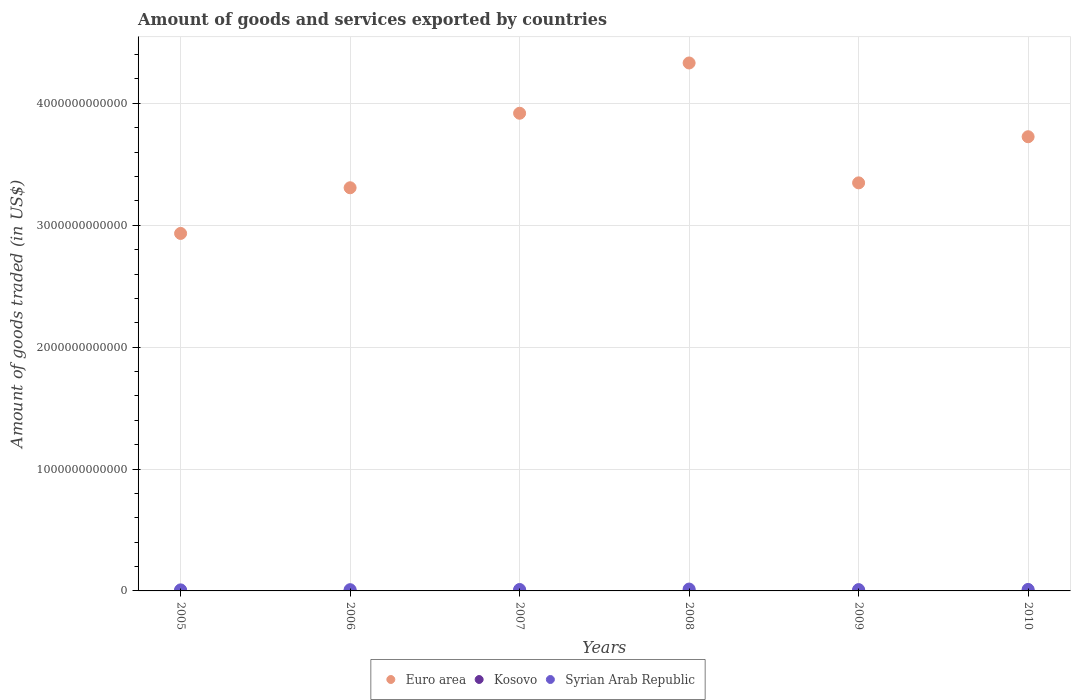How many different coloured dotlines are there?
Keep it short and to the point. 3. Is the number of dotlines equal to the number of legend labels?
Keep it short and to the point. Yes. What is the total amount of goods and services exported in Kosovo in 2005?
Keep it short and to the point. 7.96e+07. Across all years, what is the maximum total amount of goods and services exported in Syrian Arab Republic?
Your answer should be very brief. 1.53e+1. Across all years, what is the minimum total amount of goods and services exported in Euro area?
Ensure brevity in your answer.  2.93e+12. What is the total total amount of goods and services exported in Syrian Arab Republic in the graph?
Your answer should be compact. 6.91e+1. What is the difference between the total amount of goods and services exported in Euro area in 2005 and that in 2009?
Make the answer very short. -4.15e+11. What is the difference between the total amount of goods and services exported in Syrian Arab Republic in 2010 and the total amount of goods and services exported in Kosovo in 2009?
Make the answer very short. 1.20e+1. What is the average total amount of goods and services exported in Syrian Arab Republic per year?
Offer a terse response. 1.15e+1. In the year 2008, what is the difference between the total amount of goods and services exported in Kosovo and total amount of goods and services exported in Syrian Arab Republic?
Your answer should be very brief. -1.52e+1. What is the ratio of the total amount of goods and services exported in Syrian Arab Republic in 2005 to that in 2006?
Keep it short and to the point. 0.84. What is the difference between the highest and the second highest total amount of goods and services exported in Euro area?
Keep it short and to the point. 4.12e+11. What is the difference between the highest and the lowest total amount of goods and services exported in Euro area?
Offer a terse response. 1.40e+12. Does the total amount of goods and services exported in Euro area monotonically increase over the years?
Give a very brief answer. No. What is the difference between two consecutive major ticks on the Y-axis?
Offer a very short reply. 1.00e+12. Does the graph contain any zero values?
Your answer should be very brief. No. Does the graph contain grids?
Provide a succinct answer. Yes. How many legend labels are there?
Your answer should be compact. 3. What is the title of the graph?
Your response must be concise. Amount of goods and services exported by countries. What is the label or title of the X-axis?
Your answer should be very brief. Years. What is the label or title of the Y-axis?
Your answer should be very brief. Amount of goods traded (in US$). What is the Amount of goods traded (in US$) in Euro area in 2005?
Your answer should be compact. 2.93e+12. What is the Amount of goods traded (in US$) of Kosovo in 2005?
Keep it short and to the point. 7.96e+07. What is the Amount of goods traded (in US$) of Syrian Arab Republic in 2005?
Offer a very short reply. 8.60e+09. What is the Amount of goods traded (in US$) of Euro area in 2006?
Make the answer very short. 3.31e+12. What is the Amount of goods traded (in US$) of Kosovo in 2006?
Your answer should be compact. 1.24e+08. What is the Amount of goods traded (in US$) in Syrian Arab Republic in 2006?
Your answer should be compact. 1.02e+1. What is the Amount of goods traded (in US$) in Euro area in 2007?
Your answer should be very brief. 3.92e+12. What is the Amount of goods traded (in US$) of Kosovo in 2007?
Ensure brevity in your answer.  1.82e+08. What is the Amount of goods traded (in US$) of Syrian Arab Republic in 2007?
Make the answer very short. 1.18e+1. What is the Amount of goods traded (in US$) in Euro area in 2008?
Your response must be concise. 4.33e+12. What is the Amount of goods traded (in US$) in Kosovo in 2008?
Make the answer very short. 1.76e+08. What is the Amount of goods traded (in US$) of Syrian Arab Republic in 2008?
Ensure brevity in your answer.  1.53e+1. What is the Amount of goods traded (in US$) of Euro area in 2009?
Offer a very short reply. 3.35e+12. What is the Amount of goods traded (in US$) of Kosovo in 2009?
Keep it short and to the point. 2.43e+08. What is the Amount of goods traded (in US$) in Syrian Arab Republic in 2009?
Your answer should be compact. 1.09e+1. What is the Amount of goods traded (in US$) of Euro area in 2010?
Ensure brevity in your answer.  3.73e+12. What is the Amount of goods traded (in US$) of Kosovo in 2010?
Ensure brevity in your answer.  3.95e+08. What is the Amount of goods traded (in US$) in Syrian Arab Republic in 2010?
Keep it short and to the point. 1.23e+1. Across all years, what is the maximum Amount of goods traded (in US$) of Euro area?
Provide a short and direct response. 4.33e+12. Across all years, what is the maximum Amount of goods traded (in US$) in Kosovo?
Your answer should be compact. 3.95e+08. Across all years, what is the maximum Amount of goods traded (in US$) of Syrian Arab Republic?
Keep it short and to the point. 1.53e+1. Across all years, what is the minimum Amount of goods traded (in US$) in Euro area?
Ensure brevity in your answer.  2.93e+12. Across all years, what is the minimum Amount of goods traded (in US$) in Kosovo?
Your answer should be very brief. 7.96e+07. Across all years, what is the minimum Amount of goods traded (in US$) in Syrian Arab Republic?
Offer a very short reply. 8.60e+09. What is the total Amount of goods traded (in US$) of Euro area in the graph?
Provide a short and direct response. 2.16e+13. What is the total Amount of goods traded (in US$) in Kosovo in the graph?
Ensure brevity in your answer.  1.20e+09. What is the total Amount of goods traded (in US$) in Syrian Arab Republic in the graph?
Make the answer very short. 6.91e+1. What is the difference between the Amount of goods traded (in US$) of Euro area in 2005 and that in 2006?
Your response must be concise. -3.75e+11. What is the difference between the Amount of goods traded (in US$) of Kosovo in 2005 and that in 2006?
Give a very brief answer. -4.40e+07. What is the difference between the Amount of goods traded (in US$) of Syrian Arab Republic in 2005 and that in 2006?
Your response must be concise. -1.64e+09. What is the difference between the Amount of goods traded (in US$) of Euro area in 2005 and that in 2007?
Keep it short and to the point. -9.86e+11. What is the difference between the Amount of goods traded (in US$) of Kosovo in 2005 and that in 2007?
Your answer should be very brief. -1.02e+08. What is the difference between the Amount of goods traded (in US$) in Syrian Arab Republic in 2005 and that in 2007?
Offer a terse response. -3.15e+09. What is the difference between the Amount of goods traded (in US$) in Euro area in 2005 and that in 2008?
Offer a terse response. -1.40e+12. What is the difference between the Amount of goods traded (in US$) in Kosovo in 2005 and that in 2008?
Provide a short and direct response. -9.60e+07. What is the difference between the Amount of goods traded (in US$) in Syrian Arab Republic in 2005 and that in 2008?
Give a very brief answer. -6.73e+09. What is the difference between the Amount of goods traded (in US$) in Euro area in 2005 and that in 2009?
Your answer should be compact. -4.15e+11. What is the difference between the Amount of goods traded (in US$) of Kosovo in 2005 and that in 2009?
Keep it short and to the point. -1.63e+08. What is the difference between the Amount of goods traded (in US$) in Syrian Arab Republic in 2005 and that in 2009?
Make the answer very short. -2.28e+09. What is the difference between the Amount of goods traded (in US$) in Euro area in 2005 and that in 2010?
Provide a succinct answer. -7.93e+11. What is the difference between the Amount of goods traded (in US$) of Kosovo in 2005 and that in 2010?
Your answer should be compact. -3.15e+08. What is the difference between the Amount of goods traded (in US$) of Syrian Arab Republic in 2005 and that in 2010?
Offer a very short reply. -3.67e+09. What is the difference between the Amount of goods traded (in US$) of Euro area in 2006 and that in 2007?
Keep it short and to the point. -6.11e+11. What is the difference between the Amount of goods traded (in US$) in Kosovo in 2006 and that in 2007?
Your response must be concise. -5.80e+07. What is the difference between the Amount of goods traded (in US$) of Syrian Arab Republic in 2006 and that in 2007?
Your response must be concise. -1.51e+09. What is the difference between the Amount of goods traded (in US$) in Euro area in 2006 and that in 2008?
Offer a very short reply. -1.02e+12. What is the difference between the Amount of goods traded (in US$) of Kosovo in 2006 and that in 2008?
Provide a succinct answer. -5.21e+07. What is the difference between the Amount of goods traded (in US$) of Syrian Arab Republic in 2006 and that in 2008?
Offer a terse response. -5.09e+09. What is the difference between the Amount of goods traded (in US$) in Euro area in 2006 and that in 2009?
Ensure brevity in your answer.  -4.01e+1. What is the difference between the Amount of goods traded (in US$) in Kosovo in 2006 and that in 2009?
Your response must be concise. -1.19e+08. What is the difference between the Amount of goods traded (in US$) of Syrian Arab Republic in 2006 and that in 2009?
Your response must be concise. -6.39e+08. What is the difference between the Amount of goods traded (in US$) in Euro area in 2006 and that in 2010?
Your answer should be compact. -4.19e+11. What is the difference between the Amount of goods traded (in US$) of Kosovo in 2006 and that in 2010?
Give a very brief answer. -2.71e+08. What is the difference between the Amount of goods traded (in US$) of Syrian Arab Republic in 2006 and that in 2010?
Your response must be concise. -2.03e+09. What is the difference between the Amount of goods traded (in US$) in Euro area in 2007 and that in 2008?
Your answer should be very brief. -4.12e+11. What is the difference between the Amount of goods traded (in US$) of Kosovo in 2007 and that in 2008?
Provide a short and direct response. 5.88e+06. What is the difference between the Amount of goods traded (in US$) of Syrian Arab Republic in 2007 and that in 2008?
Your response must be concise. -3.58e+09. What is the difference between the Amount of goods traded (in US$) of Euro area in 2007 and that in 2009?
Provide a short and direct response. 5.71e+11. What is the difference between the Amount of goods traded (in US$) in Kosovo in 2007 and that in 2009?
Give a very brief answer. -6.15e+07. What is the difference between the Amount of goods traded (in US$) of Syrian Arab Republic in 2007 and that in 2009?
Keep it short and to the point. 8.72e+08. What is the difference between the Amount of goods traded (in US$) of Euro area in 2007 and that in 2010?
Make the answer very short. 1.93e+11. What is the difference between the Amount of goods traded (in US$) of Kosovo in 2007 and that in 2010?
Keep it short and to the point. -2.13e+08. What is the difference between the Amount of goods traded (in US$) of Syrian Arab Republic in 2007 and that in 2010?
Your answer should be compact. -5.17e+08. What is the difference between the Amount of goods traded (in US$) in Euro area in 2008 and that in 2009?
Your answer should be very brief. 9.84e+11. What is the difference between the Amount of goods traded (in US$) of Kosovo in 2008 and that in 2009?
Keep it short and to the point. -6.73e+07. What is the difference between the Amount of goods traded (in US$) of Syrian Arab Republic in 2008 and that in 2009?
Your response must be concise. 4.45e+09. What is the difference between the Amount of goods traded (in US$) in Euro area in 2008 and that in 2010?
Your response must be concise. 6.05e+11. What is the difference between the Amount of goods traded (in US$) of Kosovo in 2008 and that in 2010?
Provide a succinct answer. -2.19e+08. What is the difference between the Amount of goods traded (in US$) in Syrian Arab Republic in 2008 and that in 2010?
Your answer should be very brief. 3.06e+09. What is the difference between the Amount of goods traded (in US$) of Euro area in 2009 and that in 2010?
Your answer should be compact. -3.78e+11. What is the difference between the Amount of goods traded (in US$) of Kosovo in 2009 and that in 2010?
Make the answer very short. -1.52e+08. What is the difference between the Amount of goods traded (in US$) of Syrian Arab Republic in 2009 and that in 2010?
Ensure brevity in your answer.  -1.39e+09. What is the difference between the Amount of goods traded (in US$) in Euro area in 2005 and the Amount of goods traded (in US$) in Kosovo in 2006?
Your answer should be very brief. 2.93e+12. What is the difference between the Amount of goods traded (in US$) of Euro area in 2005 and the Amount of goods traded (in US$) of Syrian Arab Republic in 2006?
Make the answer very short. 2.92e+12. What is the difference between the Amount of goods traded (in US$) in Kosovo in 2005 and the Amount of goods traded (in US$) in Syrian Arab Republic in 2006?
Keep it short and to the point. -1.02e+1. What is the difference between the Amount of goods traded (in US$) of Euro area in 2005 and the Amount of goods traded (in US$) of Kosovo in 2007?
Make the answer very short. 2.93e+12. What is the difference between the Amount of goods traded (in US$) of Euro area in 2005 and the Amount of goods traded (in US$) of Syrian Arab Republic in 2007?
Your response must be concise. 2.92e+12. What is the difference between the Amount of goods traded (in US$) in Kosovo in 2005 and the Amount of goods traded (in US$) in Syrian Arab Republic in 2007?
Your response must be concise. -1.17e+1. What is the difference between the Amount of goods traded (in US$) of Euro area in 2005 and the Amount of goods traded (in US$) of Kosovo in 2008?
Keep it short and to the point. 2.93e+12. What is the difference between the Amount of goods traded (in US$) in Euro area in 2005 and the Amount of goods traded (in US$) in Syrian Arab Republic in 2008?
Make the answer very short. 2.92e+12. What is the difference between the Amount of goods traded (in US$) in Kosovo in 2005 and the Amount of goods traded (in US$) in Syrian Arab Republic in 2008?
Ensure brevity in your answer.  -1.53e+1. What is the difference between the Amount of goods traded (in US$) of Euro area in 2005 and the Amount of goods traded (in US$) of Kosovo in 2009?
Offer a terse response. 2.93e+12. What is the difference between the Amount of goods traded (in US$) of Euro area in 2005 and the Amount of goods traded (in US$) of Syrian Arab Republic in 2009?
Give a very brief answer. 2.92e+12. What is the difference between the Amount of goods traded (in US$) of Kosovo in 2005 and the Amount of goods traded (in US$) of Syrian Arab Republic in 2009?
Keep it short and to the point. -1.08e+1. What is the difference between the Amount of goods traded (in US$) of Euro area in 2005 and the Amount of goods traded (in US$) of Kosovo in 2010?
Your answer should be very brief. 2.93e+12. What is the difference between the Amount of goods traded (in US$) in Euro area in 2005 and the Amount of goods traded (in US$) in Syrian Arab Republic in 2010?
Provide a short and direct response. 2.92e+12. What is the difference between the Amount of goods traded (in US$) of Kosovo in 2005 and the Amount of goods traded (in US$) of Syrian Arab Republic in 2010?
Your response must be concise. -1.22e+1. What is the difference between the Amount of goods traded (in US$) in Euro area in 2006 and the Amount of goods traded (in US$) in Kosovo in 2007?
Your response must be concise. 3.31e+12. What is the difference between the Amount of goods traded (in US$) in Euro area in 2006 and the Amount of goods traded (in US$) in Syrian Arab Republic in 2007?
Your answer should be compact. 3.30e+12. What is the difference between the Amount of goods traded (in US$) of Kosovo in 2006 and the Amount of goods traded (in US$) of Syrian Arab Republic in 2007?
Keep it short and to the point. -1.16e+1. What is the difference between the Amount of goods traded (in US$) in Euro area in 2006 and the Amount of goods traded (in US$) in Kosovo in 2008?
Provide a succinct answer. 3.31e+12. What is the difference between the Amount of goods traded (in US$) in Euro area in 2006 and the Amount of goods traded (in US$) in Syrian Arab Republic in 2008?
Ensure brevity in your answer.  3.29e+12. What is the difference between the Amount of goods traded (in US$) of Kosovo in 2006 and the Amount of goods traded (in US$) of Syrian Arab Republic in 2008?
Make the answer very short. -1.52e+1. What is the difference between the Amount of goods traded (in US$) in Euro area in 2006 and the Amount of goods traded (in US$) in Kosovo in 2009?
Offer a terse response. 3.31e+12. What is the difference between the Amount of goods traded (in US$) of Euro area in 2006 and the Amount of goods traded (in US$) of Syrian Arab Republic in 2009?
Offer a terse response. 3.30e+12. What is the difference between the Amount of goods traded (in US$) of Kosovo in 2006 and the Amount of goods traded (in US$) of Syrian Arab Republic in 2009?
Provide a short and direct response. -1.08e+1. What is the difference between the Amount of goods traded (in US$) in Euro area in 2006 and the Amount of goods traded (in US$) in Kosovo in 2010?
Make the answer very short. 3.31e+12. What is the difference between the Amount of goods traded (in US$) of Euro area in 2006 and the Amount of goods traded (in US$) of Syrian Arab Republic in 2010?
Make the answer very short. 3.30e+12. What is the difference between the Amount of goods traded (in US$) of Kosovo in 2006 and the Amount of goods traded (in US$) of Syrian Arab Republic in 2010?
Offer a very short reply. -1.21e+1. What is the difference between the Amount of goods traded (in US$) of Euro area in 2007 and the Amount of goods traded (in US$) of Kosovo in 2008?
Your answer should be compact. 3.92e+12. What is the difference between the Amount of goods traded (in US$) in Euro area in 2007 and the Amount of goods traded (in US$) in Syrian Arab Republic in 2008?
Give a very brief answer. 3.90e+12. What is the difference between the Amount of goods traded (in US$) in Kosovo in 2007 and the Amount of goods traded (in US$) in Syrian Arab Republic in 2008?
Provide a succinct answer. -1.52e+1. What is the difference between the Amount of goods traded (in US$) of Euro area in 2007 and the Amount of goods traded (in US$) of Kosovo in 2009?
Offer a very short reply. 3.92e+12. What is the difference between the Amount of goods traded (in US$) in Euro area in 2007 and the Amount of goods traded (in US$) in Syrian Arab Republic in 2009?
Keep it short and to the point. 3.91e+12. What is the difference between the Amount of goods traded (in US$) of Kosovo in 2007 and the Amount of goods traded (in US$) of Syrian Arab Republic in 2009?
Your answer should be compact. -1.07e+1. What is the difference between the Amount of goods traded (in US$) in Euro area in 2007 and the Amount of goods traded (in US$) in Kosovo in 2010?
Give a very brief answer. 3.92e+12. What is the difference between the Amount of goods traded (in US$) in Euro area in 2007 and the Amount of goods traded (in US$) in Syrian Arab Republic in 2010?
Offer a very short reply. 3.91e+12. What is the difference between the Amount of goods traded (in US$) in Kosovo in 2007 and the Amount of goods traded (in US$) in Syrian Arab Republic in 2010?
Make the answer very short. -1.21e+1. What is the difference between the Amount of goods traded (in US$) of Euro area in 2008 and the Amount of goods traded (in US$) of Kosovo in 2009?
Your response must be concise. 4.33e+12. What is the difference between the Amount of goods traded (in US$) in Euro area in 2008 and the Amount of goods traded (in US$) in Syrian Arab Republic in 2009?
Offer a very short reply. 4.32e+12. What is the difference between the Amount of goods traded (in US$) in Kosovo in 2008 and the Amount of goods traded (in US$) in Syrian Arab Republic in 2009?
Provide a succinct answer. -1.07e+1. What is the difference between the Amount of goods traded (in US$) of Euro area in 2008 and the Amount of goods traded (in US$) of Kosovo in 2010?
Offer a terse response. 4.33e+12. What is the difference between the Amount of goods traded (in US$) of Euro area in 2008 and the Amount of goods traded (in US$) of Syrian Arab Republic in 2010?
Provide a short and direct response. 4.32e+12. What is the difference between the Amount of goods traded (in US$) in Kosovo in 2008 and the Amount of goods traded (in US$) in Syrian Arab Republic in 2010?
Ensure brevity in your answer.  -1.21e+1. What is the difference between the Amount of goods traded (in US$) in Euro area in 2009 and the Amount of goods traded (in US$) in Kosovo in 2010?
Keep it short and to the point. 3.35e+12. What is the difference between the Amount of goods traded (in US$) in Euro area in 2009 and the Amount of goods traded (in US$) in Syrian Arab Republic in 2010?
Your answer should be very brief. 3.34e+12. What is the difference between the Amount of goods traded (in US$) of Kosovo in 2009 and the Amount of goods traded (in US$) of Syrian Arab Republic in 2010?
Make the answer very short. -1.20e+1. What is the average Amount of goods traded (in US$) in Euro area per year?
Offer a very short reply. 3.59e+12. What is the average Amount of goods traded (in US$) in Kosovo per year?
Give a very brief answer. 2.00e+08. What is the average Amount of goods traded (in US$) of Syrian Arab Republic per year?
Offer a very short reply. 1.15e+1. In the year 2005, what is the difference between the Amount of goods traded (in US$) of Euro area and Amount of goods traded (in US$) of Kosovo?
Ensure brevity in your answer.  2.93e+12. In the year 2005, what is the difference between the Amount of goods traded (in US$) of Euro area and Amount of goods traded (in US$) of Syrian Arab Republic?
Make the answer very short. 2.92e+12. In the year 2005, what is the difference between the Amount of goods traded (in US$) of Kosovo and Amount of goods traded (in US$) of Syrian Arab Republic?
Your answer should be very brief. -8.52e+09. In the year 2006, what is the difference between the Amount of goods traded (in US$) in Euro area and Amount of goods traded (in US$) in Kosovo?
Ensure brevity in your answer.  3.31e+12. In the year 2006, what is the difference between the Amount of goods traded (in US$) of Euro area and Amount of goods traded (in US$) of Syrian Arab Republic?
Provide a succinct answer. 3.30e+12. In the year 2006, what is the difference between the Amount of goods traded (in US$) of Kosovo and Amount of goods traded (in US$) of Syrian Arab Republic?
Ensure brevity in your answer.  -1.01e+1. In the year 2007, what is the difference between the Amount of goods traded (in US$) of Euro area and Amount of goods traded (in US$) of Kosovo?
Offer a terse response. 3.92e+12. In the year 2007, what is the difference between the Amount of goods traded (in US$) of Euro area and Amount of goods traded (in US$) of Syrian Arab Republic?
Keep it short and to the point. 3.91e+12. In the year 2007, what is the difference between the Amount of goods traded (in US$) of Kosovo and Amount of goods traded (in US$) of Syrian Arab Republic?
Give a very brief answer. -1.16e+1. In the year 2008, what is the difference between the Amount of goods traded (in US$) in Euro area and Amount of goods traded (in US$) in Kosovo?
Offer a very short reply. 4.33e+12. In the year 2008, what is the difference between the Amount of goods traded (in US$) in Euro area and Amount of goods traded (in US$) in Syrian Arab Republic?
Your answer should be very brief. 4.32e+12. In the year 2008, what is the difference between the Amount of goods traded (in US$) in Kosovo and Amount of goods traded (in US$) in Syrian Arab Republic?
Your response must be concise. -1.52e+1. In the year 2009, what is the difference between the Amount of goods traded (in US$) in Euro area and Amount of goods traded (in US$) in Kosovo?
Your response must be concise. 3.35e+12. In the year 2009, what is the difference between the Amount of goods traded (in US$) in Euro area and Amount of goods traded (in US$) in Syrian Arab Republic?
Ensure brevity in your answer.  3.34e+12. In the year 2009, what is the difference between the Amount of goods traded (in US$) of Kosovo and Amount of goods traded (in US$) of Syrian Arab Republic?
Make the answer very short. -1.06e+1. In the year 2010, what is the difference between the Amount of goods traded (in US$) in Euro area and Amount of goods traded (in US$) in Kosovo?
Make the answer very short. 3.73e+12. In the year 2010, what is the difference between the Amount of goods traded (in US$) of Euro area and Amount of goods traded (in US$) of Syrian Arab Republic?
Ensure brevity in your answer.  3.71e+12. In the year 2010, what is the difference between the Amount of goods traded (in US$) in Kosovo and Amount of goods traded (in US$) in Syrian Arab Republic?
Your answer should be compact. -1.19e+1. What is the ratio of the Amount of goods traded (in US$) in Euro area in 2005 to that in 2006?
Offer a very short reply. 0.89. What is the ratio of the Amount of goods traded (in US$) in Kosovo in 2005 to that in 2006?
Your answer should be very brief. 0.64. What is the ratio of the Amount of goods traded (in US$) in Syrian Arab Republic in 2005 to that in 2006?
Your answer should be very brief. 0.84. What is the ratio of the Amount of goods traded (in US$) in Euro area in 2005 to that in 2007?
Offer a very short reply. 0.75. What is the ratio of the Amount of goods traded (in US$) in Kosovo in 2005 to that in 2007?
Keep it short and to the point. 0.44. What is the ratio of the Amount of goods traded (in US$) of Syrian Arab Republic in 2005 to that in 2007?
Offer a very short reply. 0.73. What is the ratio of the Amount of goods traded (in US$) in Euro area in 2005 to that in 2008?
Provide a succinct answer. 0.68. What is the ratio of the Amount of goods traded (in US$) of Kosovo in 2005 to that in 2008?
Provide a succinct answer. 0.45. What is the ratio of the Amount of goods traded (in US$) in Syrian Arab Republic in 2005 to that in 2008?
Provide a succinct answer. 0.56. What is the ratio of the Amount of goods traded (in US$) in Euro area in 2005 to that in 2009?
Provide a succinct answer. 0.88. What is the ratio of the Amount of goods traded (in US$) in Kosovo in 2005 to that in 2009?
Your response must be concise. 0.33. What is the ratio of the Amount of goods traded (in US$) in Syrian Arab Republic in 2005 to that in 2009?
Ensure brevity in your answer.  0.79. What is the ratio of the Amount of goods traded (in US$) of Euro area in 2005 to that in 2010?
Your response must be concise. 0.79. What is the ratio of the Amount of goods traded (in US$) in Kosovo in 2005 to that in 2010?
Your response must be concise. 0.2. What is the ratio of the Amount of goods traded (in US$) of Syrian Arab Republic in 2005 to that in 2010?
Offer a terse response. 0.7. What is the ratio of the Amount of goods traded (in US$) in Euro area in 2006 to that in 2007?
Offer a terse response. 0.84. What is the ratio of the Amount of goods traded (in US$) of Kosovo in 2006 to that in 2007?
Ensure brevity in your answer.  0.68. What is the ratio of the Amount of goods traded (in US$) in Syrian Arab Republic in 2006 to that in 2007?
Your answer should be very brief. 0.87. What is the ratio of the Amount of goods traded (in US$) of Euro area in 2006 to that in 2008?
Provide a succinct answer. 0.76. What is the ratio of the Amount of goods traded (in US$) in Kosovo in 2006 to that in 2008?
Offer a very short reply. 0.7. What is the ratio of the Amount of goods traded (in US$) in Syrian Arab Republic in 2006 to that in 2008?
Offer a terse response. 0.67. What is the ratio of the Amount of goods traded (in US$) in Kosovo in 2006 to that in 2009?
Keep it short and to the point. 0.51. What is the ratio of the Amount of goods traded (in US$) in Syrian Arab Republic in 2006 to that in 2009?
Make the answer very short. 0.94. What is the ratio of the Amount of goods traded (in US$) in Euro area in 2006 to that in 2010?
Give a very brief answer. 0.89. What is the ratio of the Amount of goods traded (in US$) of Kosovo in 2006 to that in 2010?
Offer a very short reply. 0.31. What is the ratio of the Amount of goods traded (in US$) in Syrian Arab Republic in 2006 to that in 2010?
Make the answer very short. 0.83. What is the ratio of the Amount of goods traded (in US$) in Euro area in 2007 to that in 2008?
Provide a short and direct response. 0.9. What is the ratio of the Amount of goods traded (in US$) of Kosovo in 2007 to that in 2008?
Your answer should be very brief. 1.03. What is the ratio of the Amount of goods traded (in US$) of Syrian Arab Republic in 2007 to that in 2008?
Provide a short and direct response. 0.77. What is the ratio of the Amount of goods traded (in US$) of Euro area in 2007 to that in 2009?
Provide a succinct answer. 1.17. What is the ratio of the Amount of goods traded (in US$) of Kosovo in 2007 to that in 2009?
Your response must be concise. 0.75. What is the ratio of the Amount of goods traded (in US$) in Syrian Arab Republic in 2007 to that in 2009?
Provide a short and direct response. 1.08. What is the ratio of the Amount of goods traded (in US$) of Euro area in 2007 to that in 2010?
Make the answer very short. 1.05. What is the ratio of the Amount of goods traded (in US$) of Kosovo in 2007 to that in 2010?
Give a very brief answer. 0.46. What is the ratio of the Amount of goods traded (in US$) in Syrian Arab Republic in 2007 to that in 2010?
Your response must be concise. 0.96. What is the ratio of the Amount of goods traded (in US$) in Euro area in 2008 to that in 2009?
Provide a succinct answer. 1.29. What is the ratio of the Amount of goods traded (in US$) in Kosovo in 2008 to that in 2009?
Your answer should be compact. 0.72. What is the ratio of the Amount of goods traded (in US$) of Syrian Arab Republic in 2008 to that in 2009?
Offer a terse response. 1.41. What is the ratio of the Amount of goods traded (in US$) of Euro area in 2008 to that in 2010?
Keep it short and to the point. 1.16. What is the ratio of the Amount of goods traded (in US$) of Kosovo in 2008 to that in 2010?
Offer a very short reply. 0.44. What is the ratio of the Amount of goods traded (in US$) in Syrian Arab Republic in 2008 to that in 2010?
Provide a short and direct response. 1.25. What is the ratio of the Amount of goods traded (in US$) in Euro area in 2009 to that in 2010?
Ensure brevity in your answer.  0.9. What is the ratio of the Amount of goods traded (in US$) in Kosovo in 2009 to that in 2010?
Provide a short and direct response. 0.62. What is the ratio of the Amount of goods traded (in US$) of Syrian Arab Republic in 2009 to that in 2010?
Your answer should be very brief. 0.89. What is the difference between the highest and the second highest Amount of goods traded (in US$) in Euro area?
Give a very brief answer. 4.12e+11. What is the difference between the highest and the second highest Amount of goods traded (in US$) in Kosovo?
Make the answer very short. 1.52e+08. What is the difference between the highest and the second highest Amount of goods traded (in US$) in Syrian Arab Republic?
Offer a very short reply. 3.06e+09. What is the difference between the highest and the lowest Amount of goods traded (in US$) in Euro area?
Provide a succinct answer. 1.40e+12. What is the difference between the highest and the lowest Amount of goods traded (in US$) in Kosovo?
Give a very brief answer. 3.15e+08. What is the difference between the highest and the lowest Amount of goods traded (in US$) of Syrian Arab Republic?
Your answer should be compact. 6.73e+09. 